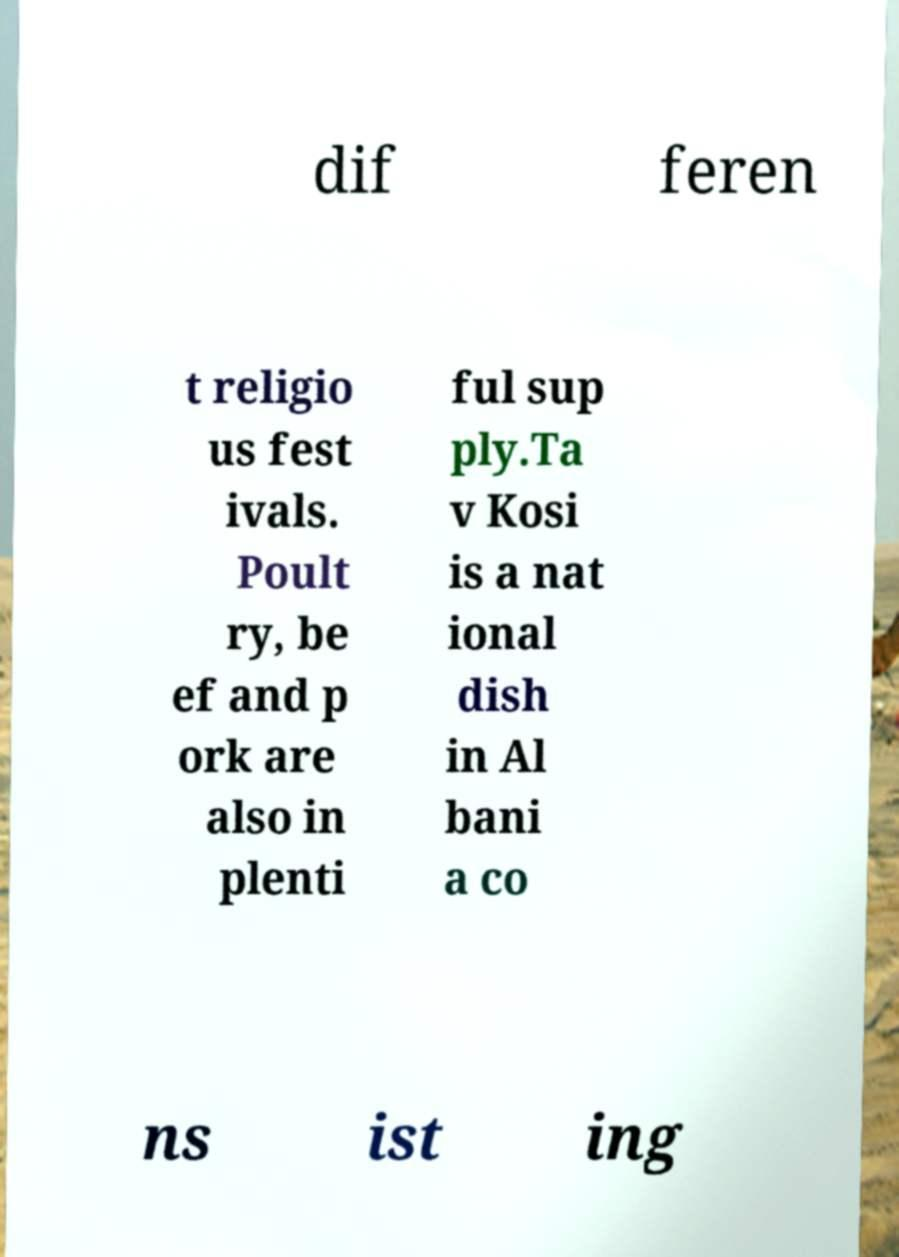For documentation purposes, I need the text within this image transcribed. Could you provide that? dif feren t religio us fest ivals. Poult ry, be ef and p ork are also in plenti ful sup ply.Ta v Kosi is a nat ional dish in Al bani a co ns ist ing 